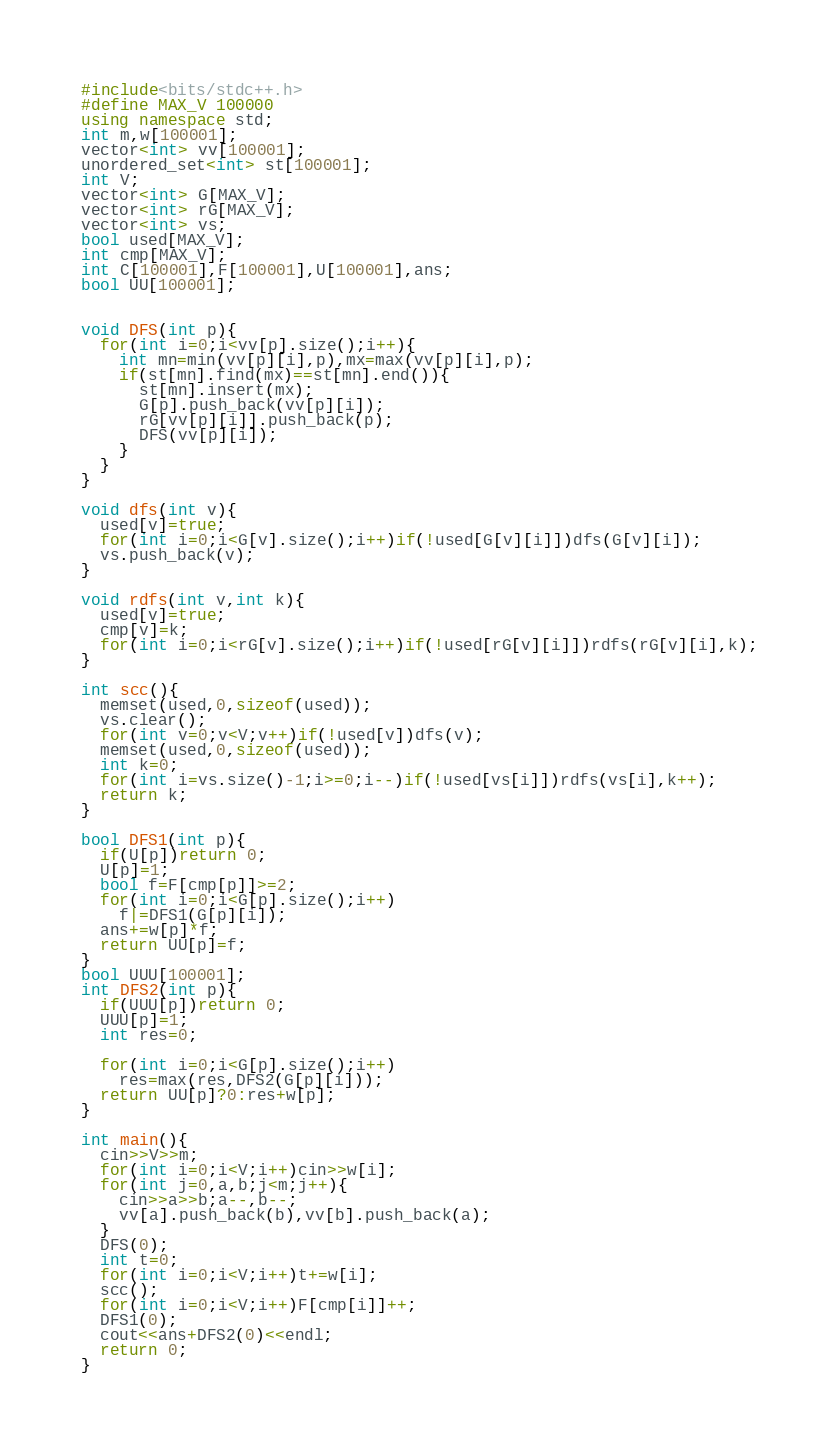<code> <loc_0><loc_0><loc_500><loc_500><_C++_>#include<bits/stdc++.h>
#define MAX_V 100000
using namespace std;
int m,w[100001];
vector<int> vv[100001];
unordered_set<int> st[100001];
int V;
vector<int> G[MAX_V];
vector<int> rG[MAX_V];
vector<int> vs;
bool used[MAX_V];
int cmp[MAX_V];
int C[100001],F[100001],U[100001],ans;
bool UU[100001];


void DFS(int p){
  for(int i=0;i<vv[p].size();i++){
    int mn=min(vv[p][i],p),mx=max(vv[p][i],p);
    if(st[mn].find(mx)==st[mn].end()){
      st[mn].insert(mx);
      G[p].push_back(vv[p][i]);
      rG[vv[p][i]].push_back(p);
      DFS(vv[p][i]);
    }
  }
}

void dfs(int v){
  used[v]=true;
  for(int i=0;i<G[v].size();i++)if(!used[G[v][i]])dfs(G[v][i]);
  vs.push_back(v);
}

void rdfs(int v,int k){
  used[v]=true;
  cmp[v]=k;
  for(int i=0;i<rG[v].size();i++)if(!used[rG[v][i]])rdfs(rG[v][i],k);
}

int scc(){
  memset(used,0,sizeof(used));
  vs.clear();
  for(int v=0;v<V;v++)if(!used[v])dfs(v);
  memset(used,0,sizeof(used));
  int k=0;
  for(int i=vs.size()-1;i>=0;i--)if(!used[vs[i]])rdfs(vs[i],k++);
  return k;
}

bool DFS1(int p){
  if(U[p])return 0;
  U[p]=1;
  bool f=F[cmp[p]]>=2;
  for(int i=0;i<G[p].size();i++)
    f|=DFS1(G[p][i]);
  ans+=w[p]*f;
  return UU[p]=f;
}
bool UUU[100001];
int DFS2(int p){
  if(UUU[p])return 0;
  UUU[p]=1;
  int res=0;
  
  for(int i=0;i<G[p].size();i++)
    res=max(res,DFS2(G[p][i]));  
  return UU[p]?0:res+w[p];
}

int main(){
  cin>>V>>m;
  for(int i=0;i<V;i++)cin>>w[i];
  for(int j=0,a,b;j<m;j++){
    cin>>a>>b;a--,b--;
    vv[a].push_back(b),vv[b].push_back(a);
  }
  DFS(0);
  int t=0;
  for(int i=0;i<V;i++)t+=w[i];
  scc();
  for(int i=0;i<V;i++)F[cmp[i]]++;
  DFS1(0);
  cout<<ans+DFS2(0)<<endl;
  return 0;
}</code> 